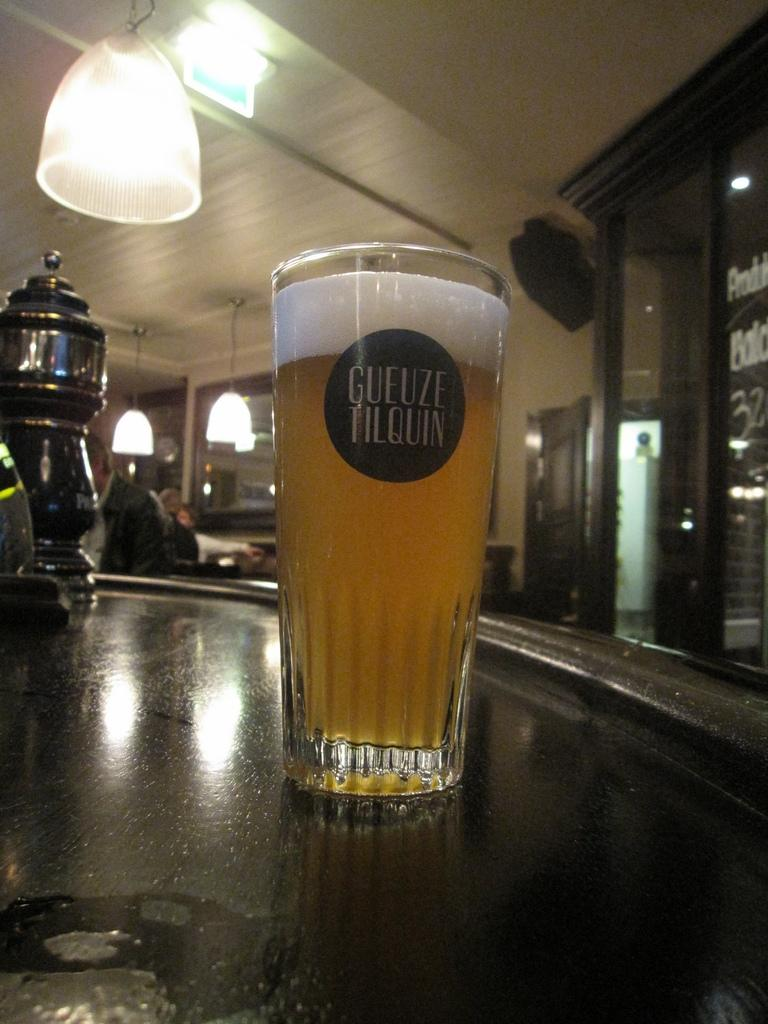What is in the glass that is visible in the image? There is some liquid in the glass in the image. What is beneath the glass? There is an object beneath the glass. What is behind the glass? There is a wall behind the glass. What type of door is visible in the image? There is a glass door in the image. What is visible at the top of the image? There are lights visible at the top of the image. What type of shirt is the glass wearing in the image? The glass is not wearing a shirt, as it is an inanimate object and does not have clothing. 